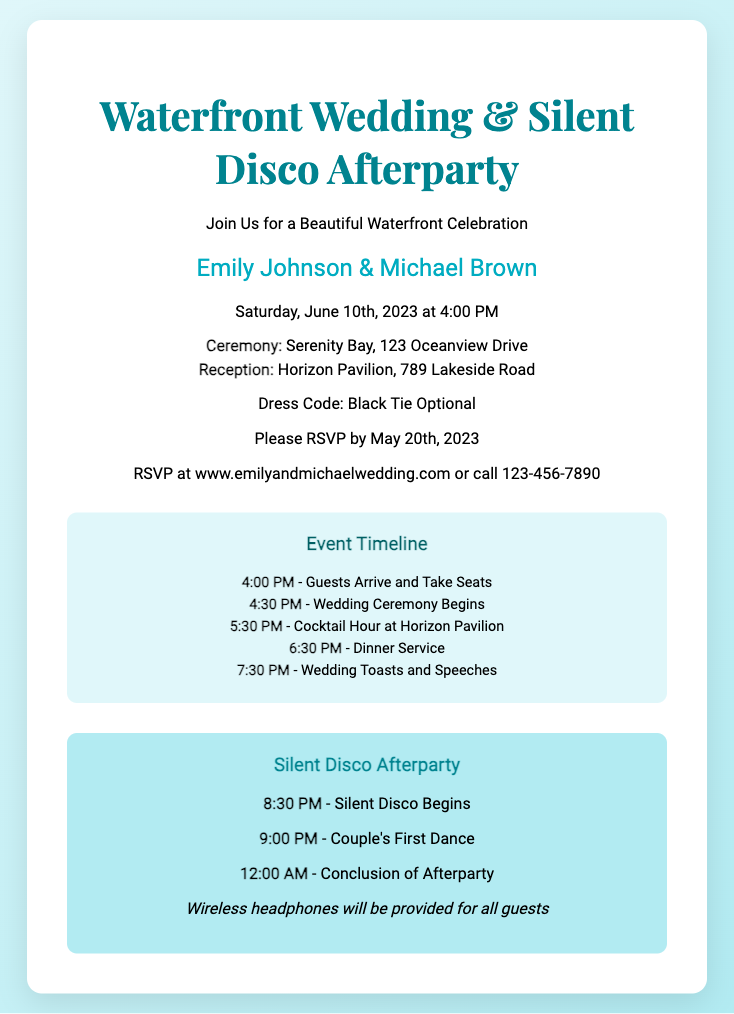What are the names of the couple? The invitation specifically names the couple as Emily Johnson and Michael Brown.
Answer: Emily Johnson & Michael Brown What is the date of the wedding? The wedding date is clearly stated in the document as June 10th, 2023.
Answer: June 10th, 2023 Where is the ceremony taking place? The document specifies that the ceremony will be held at Serenity Bay, providing the venue name and address.
Answer: Serenity Bay, 123 Oceanview Drive What time does the Silent Disco begin? The timeline in the invitation indicates that the Silent Disco starts at 8:30 PM.
Answer: 8:30 PM What is the dress code for the wedding? The dress code is mentioned in the invitation, allowing guests to choose their attire.
Answer: Black Tie Optional How long does the afterparty last? By evaluating the event timeline, the afterparty starts at 8:30 PM and concludes at midnight, indicating its duration.
Answer: 3.5 hours What RSVP method is provided? The invitation gives two methods for RSVPing, allowing guests to respond online or by phone.
Answer: www.emilyandmichaelwedding.com or call 123-456-7890 What event occurs after the Cocktail Hour? The document states that after the Cocktail Hour, the dinner service begins at 6:30 PM.
Answer: Dinner Service What will be provided for guests at the Silent Disco? The invitation mentions that wireless headphones will be provided for all guests attending the Silent Disco afterparty.
Answer: Wireless headphones 